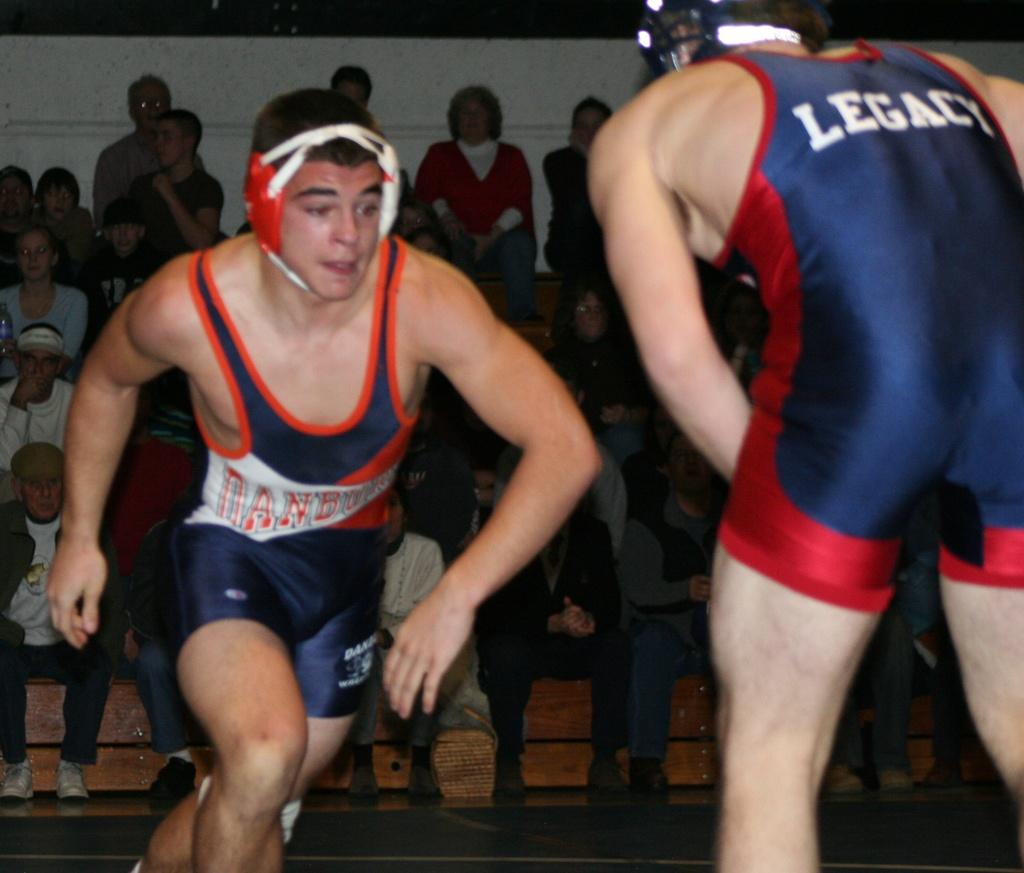<image>
Offer a succinct explanation of the picture presented. One of the wrestlers has the name Legacy on the back of his jersey. 